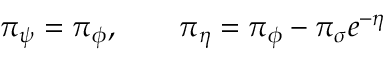Convert formula to latex. <formula><loc_0><loc_0><loc_500><loc_500>{ \pi } _ { \psi } = { \pi } _ { \phi } , \quad { \pi } _ { \eta } = { \pi } _ { \phi } - { \pi } _ { \sigma } e ^ { - \eta }</formula> 